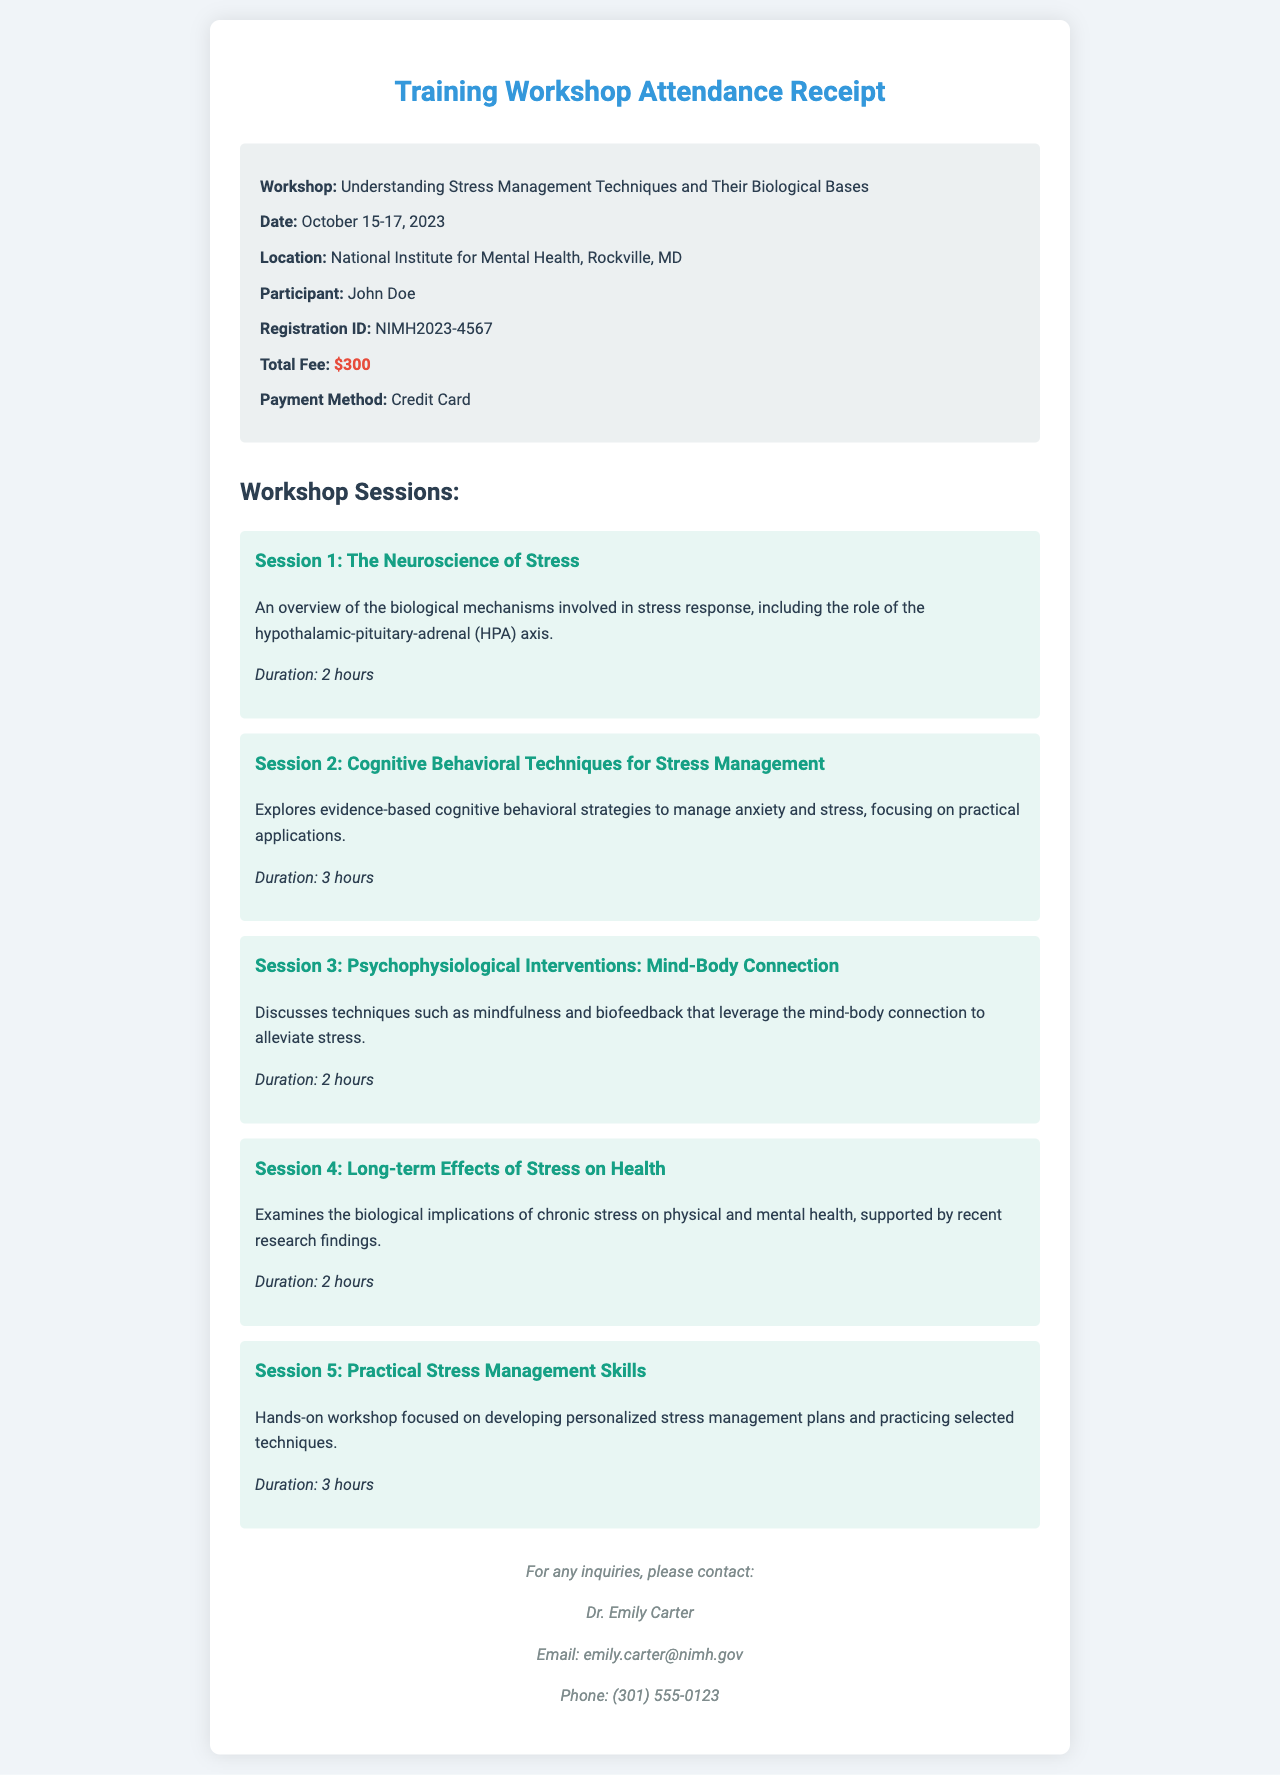What is the workshop title? The workshop title is specified in the document, which is "Understanding Stress Management Techniques and Their Biological Bases."
Answer: Understanding Stress Management Techniques and Their Biological Bases What are the dates of the workshop? The dates of the workshop are mentioned in the document as October 15-17, 2023.
Answer: October 15-17, 2023 Who is the participant? The document includes the participant's name, which is John Doe.
Answer: John Doe What is the total fee for the workshop? The total fee is clearly stated in the document as $300.
Answer: $300 How many hours is Session 2? The duration for Session 2 is included in the document, indicating that it lasts for 3 hours.
Answer: 3 hours What session discusses the HPA axis? The session that discusses the HPA axis is mentioned, which is Session 1: The Neuroscience of Stress.
Answer: Session 1: The Neuroscience of Stress Who should be contacted for inquiries? The document specifies Dr. Emily Carter as the contact person for any inquiries.
Answer: Dr. Emily Carter What payment method was used? The payment method is described in the document as Credit Card.
Answer: Credit Card How many sessions are there in total? The total number of sessions is indicated in the document, with five sessions listed.
Answer: Five sessions 